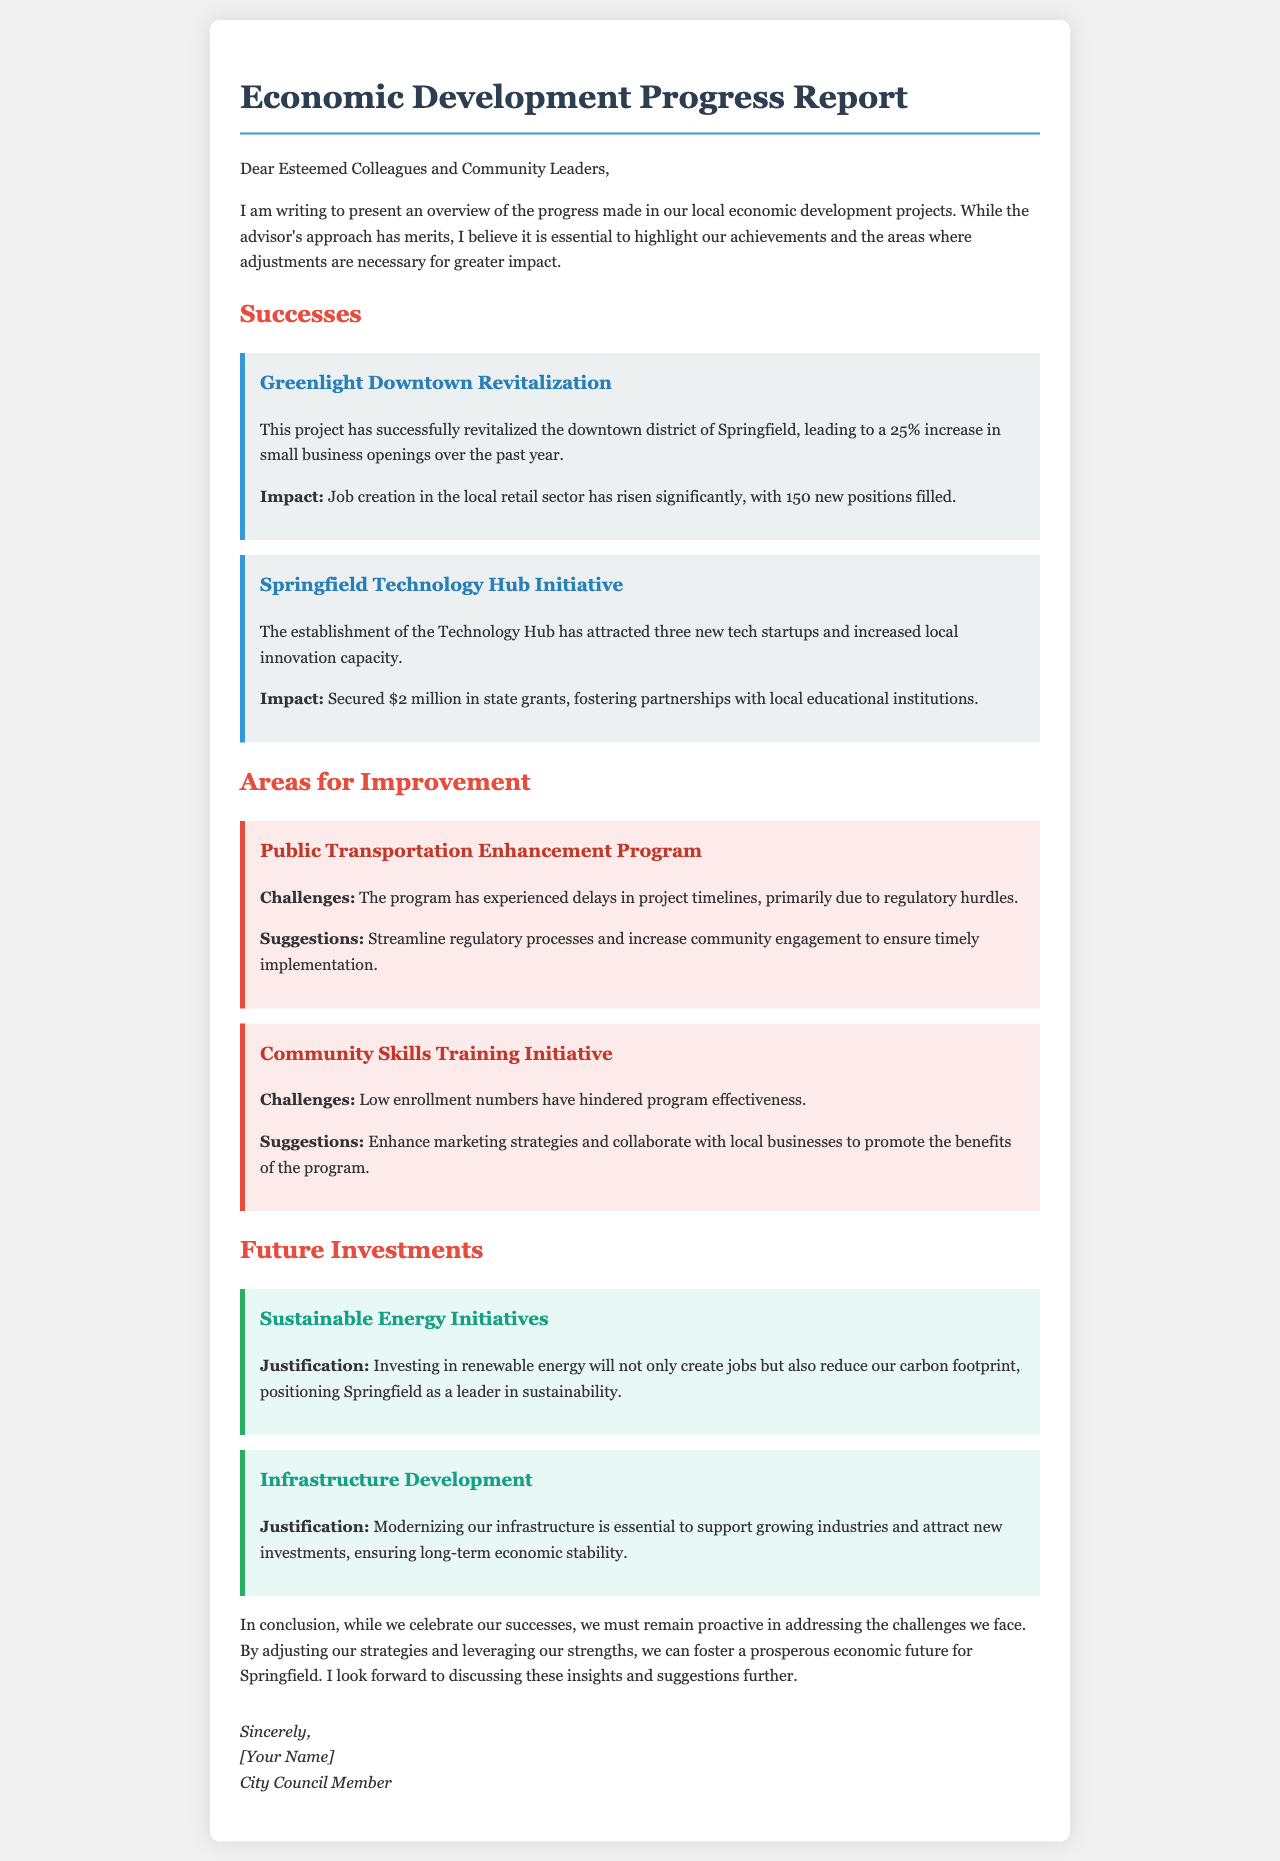What is the title of the report? The title is stated in the header of the document as "Economic Development Progress Report."
Answer: Economic Development Progress Report What project led to a 25% increase in small business openings? This information is found under the successes section, identifying the "Greenlight Downtown Revitalization" project.
Answer: Greenlight Downtown Revitalization How many new positions were filled due to the downtown revitalization? The document specifies that 150 new positions were filled as a result of the project.
Answer: 150 What major challenges does the Public Transportation Enhancement Program face? The challenges are noted in the areas for improvement section, namely "regulatory hurdles."
Answer: Regulatory hurdles What are the two suggested future investments mentioned? This includes "Sustainable Energy Initiatives" and "Infrastructure Development," as outlined in the future investments section.
Answer: Sustainable Energy Initiatives, Infrastructure Development How much funding was secured for the Springfield Technology Hub Initiative? The document states that $2 million in state grants was secured for this initiative.
Answer: $2 million What marketing strategy is suggested for the Community Skills Training Initiative? The document suggests enhancing marketing strategies to promote the benefits of the program.
Answer: Enhance marketing strategies Which project attracted three new tech startups? The project you're inquiring about is the "Springfield Technology Hub Initiative," mentioned in the successes section.
Answer: Springfield Technology Hub Initiative What is the position of the author of the letter? The document indicates that the author is a "City Council Member."
Answer: City Council Member 